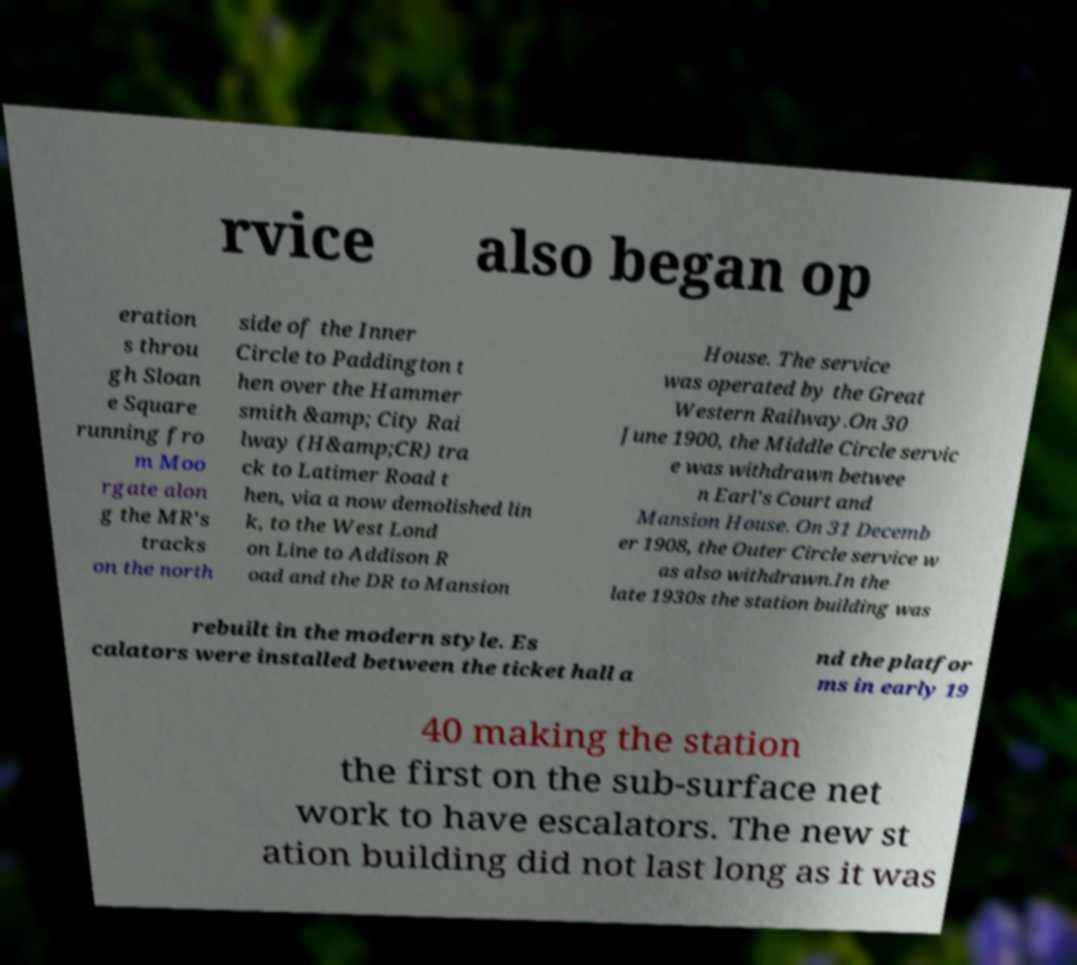Could you assist in decoding the text presented in this image and type it out clearly? rvice also began op eration s throu gh Sloan e Square running fro m Moo rgate alon g the MR's tracks on the north side of the Inner Circle to Paddington t hen over the Hammer smith &amp; City Rai lway (H&amp;CR) tra ck to Latimer Road t hen, via a now demolished lin k, to the West Lond on Line to Addison R oad and the DR to Mansion House. The service was operated by the Great Western Railway.On 30 June 1900, the Middle Circle servic e was withdrawn betwee n Earl's Court and Mansion House. On 31 Decemb er 1908, the Outer Circle service w as also withdrawn.In the late 1930s the station building was rebuilt in the modern style. Es calators were installed between the ticket hall a nd the platfor ms in early 19 40 making the station the first on the sub-surface net work to have escalators. The new st ation building did not last long as it was 